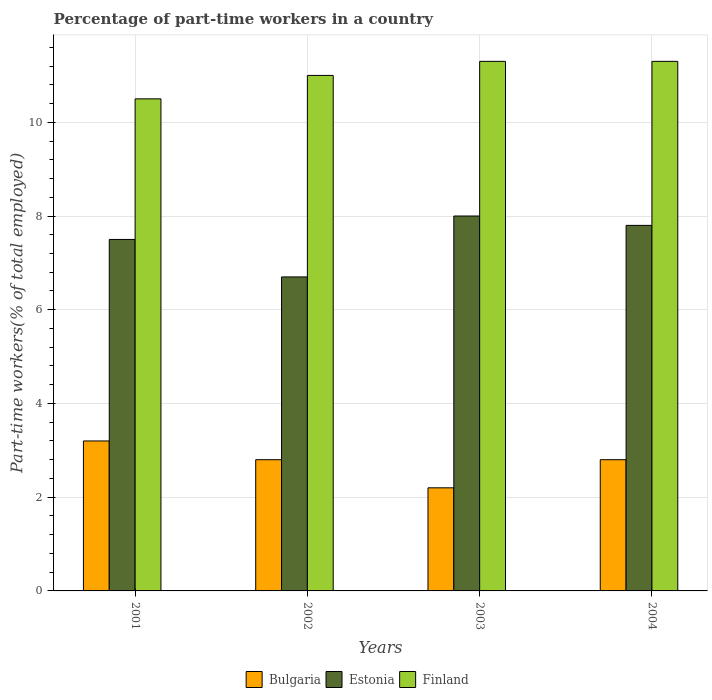How many groups of bars are there?
Your answer should be very brief. 4. Are the number of bars per tick equal to the number of legend labels?
Offer a terse response. Yes. How many bars are there on the 4th tick from the left?
Offer a terse response. 3. What is the percentage of part-time workers in Bulgaria in 2003?
Ensure brevity in your answer.  2.2. Across all years, what is the minimum percentage of part-time workers in Bulgaria?
Ensure brevity in your answer.  2.2. In which year was the percentage of part-time workers in Bulgaria minimum?
Offer a very short reply. 2003. What is the total percentage of part-time workers in Finland in the graph?
Ensure brevity in your answer.  44.1. What is the difference between the percentage of part-time workers in Bulgaria in 2003 and the percentage of part-time workers in Estonia in 2001?
Provide a short and direct response. -5.3. What is the average percentage of part-time workers in Bulgaria per year?
Your response must be concise. 2.75. In the year 2001, what is the difference between the percentage of part-time workers in Finland and percentage of part-time workers in Bulgaria?
Ensure brevity in your answer.  7.3. In how many years, is the percentage of part-time workers in Bulgaria greater than 4.8 %?
Your answer should be compact. 0. What is the ratio of the percentage of part-time workers in Estonia in 2003 to that in 2004?
Offer a very short reply. 1.03. Is the difference between the percentage of part-time workers in Finland in 2003 and 2004 greater than the difference between the percentage of part-time workers in Bulgaria in 2003 and 2004?
Make the answer very short. Yes. What is the difference between the highest and the second highest percentage of part-time workers in Finland?
Ensure brevity in your answer.  0. What is the difference between the highest and the lowest percentage of part-time workers in Finland?
Your answer should be compact. 0.8. Is the sum of the percentage of part-time workers in Estonia in 2002 and 2004 greater than the maximum percentage of part-time workers in Bulgaria across all years?
Offer a terse response. Yes. What does the 2nd bar from the right in 2001 represents?
Your response must be concise. Estonia. Is it the case that in every year, the sum of the percentage of part-time workers in Estonia and percentage of part-time workers in Finland is greater than the percentage of part-time workers in Bulgaria?
Make the answer very short. Yes. How many bars are there?
Keep it short and to the point. 12. Are all the bars in the graph horizontal?
Offer a terse response. No. How many years are there in the graph?
Offer a terse response. 4. Does the graph contain any zero values?
Give a very brief answer. No. Does the graph contain grids?
Provide a short and direct response. Yes. Where does the legend appear in the graph?
Your answer should be compact. Bottom center. What is the title of the graph?
Ensure brevity in your answer.  Percentage of part-time workers in a country. What is the label or title of the X-axis?
Keep it short and to the point. Years. What is the label or title of the Y-axis?
Provide a short and direct response. Part-time workers(% of total employed). What is the Part-time workers(% of total employed) of Bulgaria in 2001?
Make the answer very short. 3.2. What is the Part-time workers(% of total employed) in Bulgaria in 2002?
Your answer should be compact. 2.8. What is the Part-time workers(% of total employed) of Estonia in 2002?
Offer a terse response. 6.7. What is the Part-time workers(% of total employed) of Bulgaria in 2003?
Provide a succinct answer. 2.2. What is the Part-time workers(% of total employed) in Finland in 2003?
Offer a very short reply. 11.3. What is the Part-time workers(% of total employed) of Bulgaria in 2004?
Your response must be concise. 2.8. What is the Part-time workers(% of total employed) of Estonia in 2004?
Ensure brevity in your answer.  7.8. What is the Part-time workers(% of total employed) of Finland in 2004?
Provide a succinct answer. 11.3. Across all years, what is the maximum Part-time workers(% of total employed) of Bulgaria?
Offer a very short reply. 3.2. Across all years, what is the maximum Part-time workers(% of total employed) of Finland?
Offer a very short reply. 11.3. Across all years, what is the minimum Part-time workers(% of total employed) in Bulgaria?
Ensure brevity in your answer.  2.2. Across all years, what is the minimum Part-time workers(% of total employed) of Estonia?
Your response must be concise. 6.7. Across all years, what is the minimum Part-time workers(% of total employed) of Finland?
Make the answer very short. 10.5. What is the total Part-time workers(% of total employed) in Bulgaria in the graph?
Make the answer very short. 11. What is the total Part-time workers(% of total employed) of Finland in the graph?
Provide a short and direct response. 44.1. What is the difference between the Part-time workers(% of total employed) in Finland in 2001 and that in 2002?
Give a very brief answer. -0.5. What is the difference between the Part-time workers(% of total employed) in Finland in 2001 and that in 2003?
Keep it short and to the point. -0.8. What is the difference between the Part-time workers(% of total employed) of Bulgaria in 2001 and that in 2004?
Offer a terse response. 0.4. What is the difference between the Part-time workers(% of total employed) of Estonia in 2002 and that in 2003?
Keep it short and to the point. -1.3. What is the difference between the Part-time workers(% of total employed) of Bulgaria in 2002 and that in 2004?
Give a very brief answer. 0. What is the difference between the Part-time workers(% of total employed) of Finland in 2002 and that in 2004?
Offer a terse response. -0.3. What is the difference between the Part-time workers(% of total employed) of Bulgaria in 2003 and that in 2004?
Your answer should be compact. -0.6. What is the difference between the Part-time workers(% of total employed) in Finland in 2003 and that in 2004?
Provide a succinct answer. 0. What is the difference between the Part-time workers(% of total employed) of Bulgaria in 2001 and the Part-time workers(% of total employed) of Finland in 2002?
Your answer should be compact. -7.8. What is the difference between the Part-time workers(% of total employed) in Estonia in 2001 and the Part-time workers(% of total employed) in Finland in 2002?
Ensure brevity in your answer.  -3.5. What is the difference between the Part-time workers(% of total employed) in Bulgaria in 2001 and the Part-time workers(% of total employed) in Estonia in 2003?
Your answer should be compact. -4.8. What is the difference between the Part-time workers(% of total employed) in Estonia in 2001 and the Part-time workers(% of total employed) in Finland in 2003?
Offer a very short reply. -3.8. What is the difference between the Part-time workers(% of total employed) of Bulgaria in 2002 and the Part-time workers(% of total employed) of Estonia in 2003?
Make the answer very short. -5.2. What is the difference between the Part-time workers(% of total employed) in Bulgaria in 2002 and the Part-time workers(% of total employed) in Finland in 2003?
Ensure brevity in your answer.  -8.5. What is the difference between the Part-time workers(% of total employed) in Estonia in 2002 and the Part-time workers(% of total employed) in Finland in 2003?
Ensure brevity in your answer.  -4.6. What is the difference between the Part-time workers(% of total employed) in Bulgaria in 2002 and the Part-time workers(% of total employed) in Estonia in 2004?
Offer a terse response. -5. What is the difference between the Part-time workers(% of total employed) in Estonia in 2002 and the Part-time workers(% of total employed) in Finland in 2004?
Your response must be concise. -4.6. What is the difference between the Part-time workers(% of total employed) in Bulgaria in 2003 and the Part-time workers(% of total employed) in Estonia in 2004?
Offer a terse response. -5.6. What is the difference between the Part-time workers(% of total employed) of Bulgaria in 2003 and the Part-time workers(% of total employed) of Finland in 2004?
Offer a terse response. -9.1. What is the difference between the Part-time workers(% of total employed) of Estonia in 2003 and the Part-time workers(% of total employed) of Finland in 2004?
Ensure brevity in your answer.  -3.3. What is the average Part-time workers(% of total employed) in Bulgaria per year?
Keep it short and to the point. 2.75. What is the average Part-time workers(% of total employed) of Estonia per year?
Your answer should be very brief. 7.5. What is the average Part-time workers(% of total employed) of Finland per year?
Your answer should be compact. 11.03. In the year 2001, what is the difference between the Part-time workers(% of total employed) of Bulgaria and Part-time workers(% of total employed) of Finland?
Your response must be concise. -7.3. In the year 2002, what is the difference between the Part-time workers(% of total employed) in Bulgaria and Part-time workers(% of total employed) in Finland?
Offer a very short reply. -8.2. In the year 2003, what is the difference between the Part-time workers(% of total employed) in Bulgaria and Part-time workers(% of total employed) in Estonia?
Provide a short and direct response. -5.8. In the year 2004, what is the difference between the Part-time workers(% of total employed) in Bulgaria and Part-time workers(% of total employed) in Estonia?
Make the answer very short. -5. In the year 2004, what is the difference between the Part-time workers(% of total employed) of Bulgaria and Part-time workers(% of total employed) of Finland?
Your answer should be compact. -8.5. In the year 2004, what is the difference between the Part-time workers(% of total employed) of Estonia and Part-time workers(% of total employed) of Finland?
Provide a succinct answer. -3.5. What is the ratio of the Part-time workers(% of total employed) in Bulgaria in 2001 to that in 2002?
Offer a terse response. 1.14. What is the ratio of the Part-time workers(% of total employed) in Estonia in 2001 to that in 2002?
Offer a very short reply. 1.12. What is the ratio of the Part-time workers(% of total employed) of Finland in 2001 to that in 2002?
Your answer should be very brief. 0.95. What is the ratio of the Part-time workers(% of total employed) in Bulgaria in 2001 to that in 2003?
Your answer should be very brief. 1.45. What is the ratio of the Part-time workers(% of total employed) in Estonia in 2001 to that in 2003?
Offer a terse response. 0.94. What is the ratio of the Part-time workers(% of total employed) in Finland in 2001 to that in 2003?
Offer a terse response. 0.93. What is the ratio of the Part-time workers(% of total employed) in Estonia in 2001 to that in 2004?
Your response must be concise. 0.96. What is the ratio of the Part-time workers(% of total employed) of Finland in 2001 to that in 2004?
Ensure brevity in your answer.  0.93. What is the ratio of the Part-time workers(% of total employed) in Bulgaria in 2002 to that in 2003?
Make the answer very short. 1.27. What is the ratio of the Part-time workers(% of total employed) in Estonia in 2002 to that in 2003?
Give a very brief answer. 0.84. What is the ratio of the Part-time workers(% of total employed) of Finland in 2002 to that in 2003?
Your response must be concise. 0.97. What is the ratio of the Part-time workers(% of total employed) in Estonia in 2002 to that in 2004?
Ensure brevity in your answer.  0.86. What is the ratio of the Part-time workers(% of total employed) in Finland in 2002 to that in 2004?
Provide a short and direct response. 0.97. What is the ratio of the Part-time workers(% of total employed) in Bulgaria in 2003 to that in 2004?
Ensure brevity in your answer.  0.79. What is the ratio of the Part-time workers(% of total employed) of Estonia in 2003 to that in 2004?
Provide a succinct answer. 1.03. What is the difference between the highest and the second highest Part-time workers(% of total employed) in Bulgaria?
Offer a very short reply. 0.4. What is the difference between the highest and the second highest Part-time workers(% of total employed) in Estonia?
Make the answer very short. 0.2. What is the difference between the highest and the second highest Part-time workers(% of total employed) of Finland?
Ensure brevity in your answer.  0. What is the difference between the highest and the lowest Part-time workers(% of total employed) in Estonia?
Give a very brief answer. 1.3. What is the difference between the highest and the lowest Part-time workers(% of total employed) of Finland?
Make the answer very short. 0.8. 